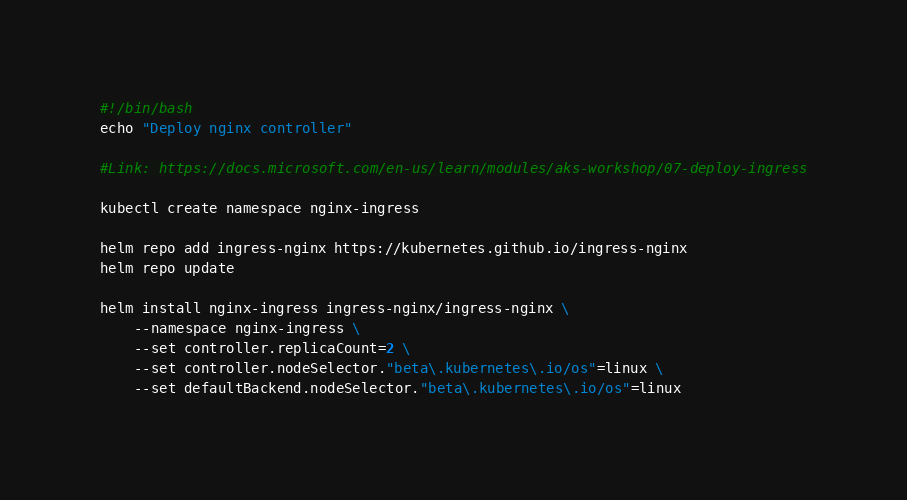<code> <loc_0><loc_0><loc_500><loc_500><_Bash_>#!/bin/bash
echo "Deploy nginx controller"

#Link: https://docs.microsoft.com/en-us/learn/modules/aks-workshop/07-deploy-ingress

kubectl create namespace nginx-ingress

helm repo add ingress-nginx https://kubernetes.github.io/ingress-nginx
helm repo update

helm install nginx-ingress ingress-nginx/ingress-nginx \
    --namespace nginx-ingress \
    --set controller.replicaCount=2 \
    --set controller.nodeSelector."beta\.kubernetes\.io/os"=linux \
    --set defaultBackend.nodeSelector."beta\.kubernetes\.io/os"=linux

</code> 